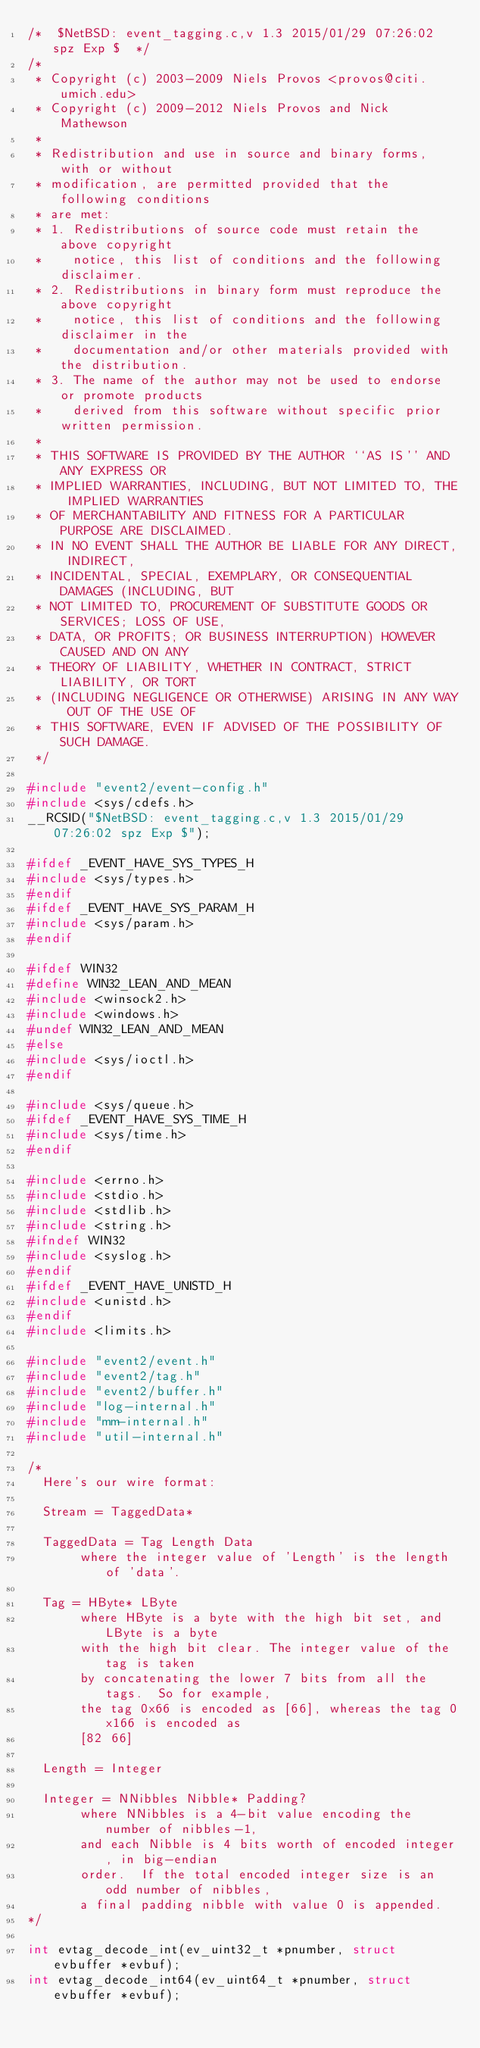Convert code to text. <code><loc_0><loc_0><loc_500><loc_500><_C_>/*	$NetBSD: event_tagging.c,v 1.3 2015/01/29 07:26:02 spz Exp $	*/
/*
 * Copyright (c) 2003-2009 Niels Provos <provos@citi.umich.edu>
 * Copyright (c) 2009-2012 Niels Provos and Nick Mathewson
 *
 * Redistribution and use in source and binary forms, with or without
 * modification, are permitted provided that the following conditions
 * are met:
 * 1. Redistributions of source code must retain the above copyright
 *    notice, this list of conditions and the following disclaimer.
 * 2. Redistributions in binary form must reproduce the above copyright
 *    notice, this list of conditions and the following disclaimer in the
 *    documentation and/or other materials provided with the distribution.
 * 3. The name of the author may not be used to endorse or promote products
 *    derived from this software without specific prior written permission.
 *
 * THIS SOFTWARE IS PROVIDED BY THE AUTHOR ``AS IS'' AND ANY EXPRESS OR
 * IMPLIED WARRANTIES, INCLUDING, BUT NOT LIMITED TO, THE IMPLIED WARRANTIES
 * OF MERCHANTABILITY AND FITNESS FOR A PARTICULAR PURPOSE ARE DISCLAIMED.
 * IN NO EVENT SHALL THE AUTHOR BE LIABLE FOR ANY DIRECT, INDIRECT,
 * INCIDENTAL, SPECIAL, EXEMPLARY, OR CONSEQUENTIAL DAMAGES (INCLUDING, BUT
 * NOT LIMITED TO, PROCUREMENT OF SUBSTITUTE GOODS OR SERVICES; LOSS OF USE,
 * DATA, OR PROFITS; OR BUSINESS INTERRUPTION) HOWEVER CAUSED AND ON ANY
 * THEORY OF LIABILITY, WHETHER IN CONTRACT, STRICT LIABILITY, OR TORT
 * (INCLUDING NEGLIGENCE OR OTHERWISE) ARISING IN ANY WAY OUT OF THE USE OF
 * THIS SOFTWARE, EVEN IF ADVISED OF THE POSSIBILITY OF SUCH DAMAGE.
 */

#include "event2/event-config.h"
#include <sys/cdefs.h>
__RCSID("$NetBSD: event_tagging.c,v 1.3 2015/01/29 07:26:02 spz Exp $");

#ifdef _EVENT_HAVE_SYS_TYPES_H
#include <sys/types.h>
#endif
#ifdef _EVENT_HAVE_SYS_PARAM_H
#include <sys/param.h>
#endif

#ifdef WIN32
#define WIN32_LEAN_AND_MEAN
#include <winsock2.h>
#include <windows.h>
#undef WIN32_LEAN_AND_MEAN
#else
#include <sys/ioctl.h>
#endif

#include <sys/queue.h>
#ifdef _EVENT_HAVE_SYS_TIME_H
#include <sys/time.h>
#endif

#include <errno.h>
#include <stdio.h>
#include <stdlib.h>
#include <string.h>
#ifndef WIN32
#include <syslog.h>
#endif
#ifdef _EVENT_HAVE_UNISTD_H
#include <unistd.h>
#endif
#include <limits.h>

#include "event2/event.h"
#include "event2/tag.h"
#include "event2/buffer.h"
#include "log-internal.h"
#include "mm-internal.h"
#include "util-internal.h"

/*
  Here's our wire format:

  Stream = TaggedData*

  TaggedData = Tag Length Data
       where the integer value of 'Length' is the length of 'data'.

  Tag = HByte* LByte
       where HByte is a byte with the high bit set, and LByte is a byte
       with the high bit clear. The integer value of the tag is taken
       by concatenating the lower 7 bits from all the tags.  So for example,
       the tag 0x66 is encoded as [66], whereas the tag 0x166 is encoded as
       [82 66]

  Length = Integer

  Integer = NNibbles Nibble* Padding?
       where NNibbles is a 4-bit value encoding the number of nibbles-1,
       and each Nibble is 4 bits worth of encoded integer, in big-endian
       order.  If the total encoded integer size is an odd number of nibbles,
       a final padding nibble with value 0 is appended.
*/

int evtag_decode_int(ev_uint32_t *pnumber, struct evbuffer *evbuf);
int evtag_decode_int64(ev_uint64_t *pnumber, struct evbuffer *evbuf);</code> 